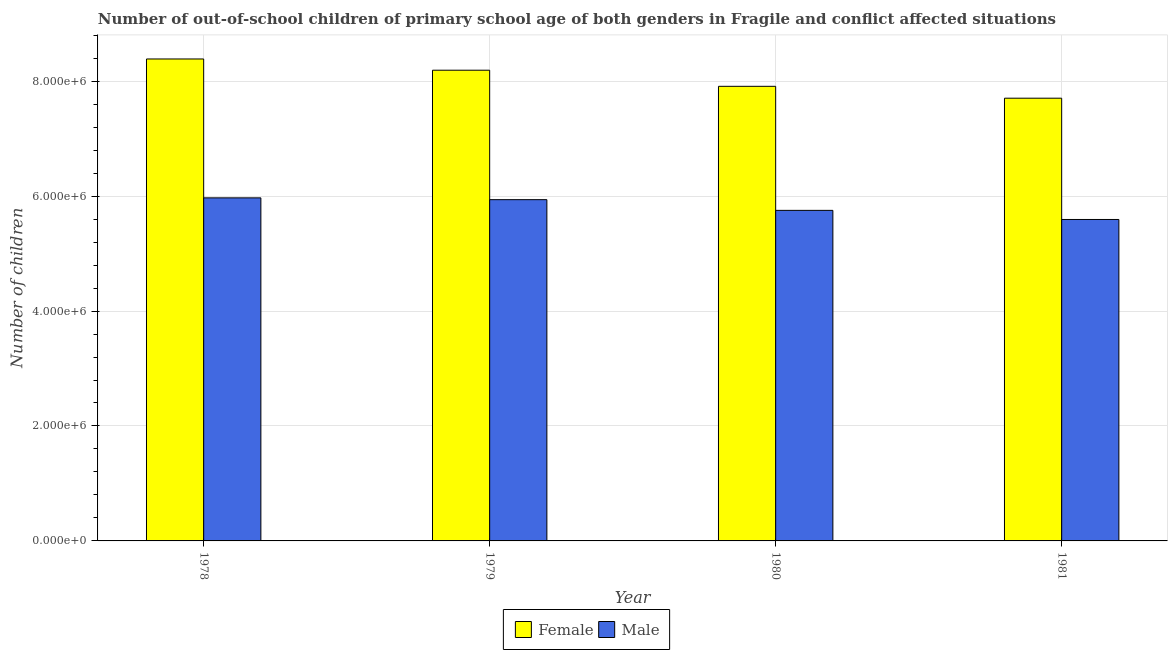How many groups of bars are there?
Give a very brief answer. 4. In how many cases, is the number of bars for a given year not equal to the number of legend labels?
Make the answer very short. 0. What is the number of female out-of-school students in 1980?
Keep it short and to the point. 7.91e+06. Across all years, what is the maximum number of male out-of-school students?
Your answer should be compact. 5.97e+06. Across all years, what is the minimum number of male out-of-school students?
Offer a terse response. 5.59e+06. In which year was the number of male out-of-school students maximum?
Offer a very short reply. 1978. In which year was the number of male out-of-school students minimum?
Your response must be concise. 1981. What is the total number of male out-of-school students in the graph?
Your answer should be compact. 2.33e+07. What is the difference between the number of male out-of-school students in 1980 and that in 1981?
Give a very brief answer. 1.58e+05. What is the difference between the number of female out-of-school students in 1981 and the number of male out-of-school students in 1978?
Give a very brief answer. -6.83e+05. What is the average number of male out-of-school students per year?
Make the answer very short. 5.81e+06. In the year 1981, what is the difference between the number of female out-of-school students and number of male out-of-school students?
Your answer should be very brief. 0. In how many years, is the number of female out-of-school students greater than 7200000?
Provide a short and direct response. 4. What is the ratio of the number of female out-of-school students in 1978 to that in 1980?
Keep it short and to the point. 1.06. Is the difference between the number of male out-of-school students in 1980 and 1981 greater than the difference between the number of female out-of-school students in 1980 and 1981?
Your answer should be compact. No. What is the difference between the highest and the second highest number of male out-of-school students?
Offer a very short reply. 3.12e+04. What is the difference between the highest and the lowest number of female out-of-school students?
Your response must be concise. 6.83e+05. Is the sum of the number of male out-of-school students in 1978 and 1980 greater than the maximum number of female out-of-school students across all years?
Your answer should be compact. Yes. What does the 1st bar from the left in 1979 represents?
Keep it short and to the point. Female. What does the 1st bar from the right in 1979 represents?
Offer a very short reply. Male. How many bars are there?
Offer a very short reply. 8. How many years are there in the graph?
Provide a succinct answer. 4. How are the legend labels stacked?
Make the answer very short. Horizontal. What is the title of the graph?
Your answer should be compact. Number of out-of-school children of primary school age of both genders in Fragile and conflict affected situations. What is the label or title of the Y-axis?
Offer a very short reply. Number of children. What is the Number of children in Female in 1978?
Your answer should be very brief. 8.39e+06. What is the Number of children in Male in 1978?
Offer a very short reply. 5.97e+06. What is the Number of children in Female in 1979?
Give a very brief answer. 8.19e+06. What is the Number of children in Male in 1979?
Ensure brevity in your answer.  5.94e+06. What is the Number of children of Female in 1980?
Provide a succinct answer. 7.91e+06. What is the Number of children in Male in 1980?
Your response must be concise. 5.75e+06. What is the Number of children in Female in 1981?
Make the answer very short. 7.70e+06. What is the Number of children in Male in 1981?
Ensure brevity in your answer.  5.59e+06. Across all years, what is the maximum Number of children in Female?
Provide a succinct answer. 8.39e+06. Across all years, what is the maximum Number of children in Male?
Give a very brief answer. 5.97e+06. Across all years, what is the minimum Number of children in Female?
Provide a short and direct response. 7.70e+06. Across all years, what is the minimum Number of children in Male?
Provide a short and direct response. 5.59e+06. What is the total Number of children in Female in the graph?
Offer a very short reply. 3.22e+07. What is the total Number of children of Male in the graph?
Your response must be concise. 2.33e+07. What is the difference between the Number of children of Female in 1978 and that in 1979?
Provide a succinct answer. 1.96e+05. What is the difference between the Number of children in Male in 1978 and that in 1979?
Provide a succinct answer. 3.12e+04. What is the difference between the Number of children of Female in 1978 and that in 1980?
Provide a short and direct response. 4.76e+05. What is the difference between the Number of children in Male in 1978 and that in 1980?
Offer a very short reply. 2.18e+05. What is the difference between the Number of children in Female in 1978 and that in 1981?
Give a very brief answer. 6.83e+05. What is the difference between the Number of children of Male in 1978 and that in 1981?
Keep it short and to the point. 3.76e+05. What is the difference between the Number of children in Female in 1979 and that in 1980?
Provide a succinct answer. 2.80e+05. What is the difference between the Number of children of Male in 1979 and that in 1980?
Your response must be concise. 1.86e+05. What is the difference between the Number of children in Female in 1979 and that in 1981?
Provide a short and direct response. 4.87e+05. What is the difference between the Number of children in Male in 1979 and that in 1981?
Ensure brevity in your answer.  3.45e+05. What is the difference between the Number of children of Female in 1980 and that in 1981?
Offer a terse response. 2.07e+05. What is the difference between the Number of children of Male in 1980 and that in 1981?
Your answer should be very brief. 1.58e+05. What is the difference between the Number of children of Female in 1978 and the Number of children of Male in 1979?
Ensure brevity in your answer.  2.45e+06. What is the difference between the Number of children in Female in 1978 and the Number of children in Male in 1980?
Provide a succinct answer. 2.63e+06. What is the difference between the Number of children of Female in 1978 and the Number of children of Male in 1981?
Your response must be concise. 2.79e+06. What is the difference between the Number of children in Female in 1979 and the Number of children in Male in 1980?
Your answer should be very brief. 2.44e+06. What is the difference between the Number of children in Female in 1979 and the Number of children in Male in 1981?
Offer a very short reply. 2.60e+06. What is the difference between the Number of children in Female in 1980 and the Number of children in Male in 1981?
Provide a succinct answer. 2.32e+06. What is the average Number of children in Female per year?
Provide a succinct answer. 8.05e+06. What is the average Number of children in Male per year?
Make the answer very short. 5.81e+06. In the year 1978, what is the difference between the Number of children of Female and Number of children of Male?
Your answer should be compact. 2.42e+06. In the year 1979, what is the difference between the Number of children in Female and Number of children in Male?
Offer a terse response. 2.25e+06. In the year 1980, what is the difference between the Number of children in Female and Number of children in Male?
Keep it short and to the point. 2.16e+06. In the year 1981, what is the difference between the Number of children of Female and Number of children of Male?
Keep it short and to the point. 2.11e+06. What is the ratio of the Number of children of Female in 1978 to that in 1979?
Keep it short and to the point. 1.02. What is the ratio of the Number of children of Female in 1978 to that in 1980?
Provide a short and direct response. 1.06. What is the ratio of the Number of children of Male in 1978 to that in 1980?
Offer a very short reply. 1.04. What is the ratio of the Number of children of Female in 1978 to that in 1981?
Your response must be concise. 1.09. What is the ratio of the Number of children in Male in 1978 to that in 1981?
Give a very brief answer. 1.07. What is the ratio of the Number of children of Female in 1979 to that in 1980?
Provide a succinct answer. 1.04. What is the ratio of the Number of children in Male in 1979 to that in 1980?
Offer a very short reply. 1.03. What is the ratio of the Number of children in Female in 1979 to that in 1981?
Offer a very short reply. 1.06. What is the ratio of the Number of children of Male in 1979 to that in 1981?
Your answer should be compact. 1.06. What is the ratio of the Number of children in Female in 1980 to that in 1981?
Your answer should be compact. 1.03. What is the ratio of the Number of children of Male in 1980 to that in 1981?
Keep it short and to the point. 1.03. What is the difference between the highest and the second highest Number of children in Female?
Ensure brevity in your answer.  1.96e+05. What is the difference between the highest and the second highest Number of children of Male?
Your answer should be very brief. 3.12e+04. What is the difference between the highest and the lowest Number of children in Female?
Provide a succinct answer. 6.83e+05. What is the difference between the highest and the lowest Number of children of Male?
Your answer should be very brief. 3.76e+05. 